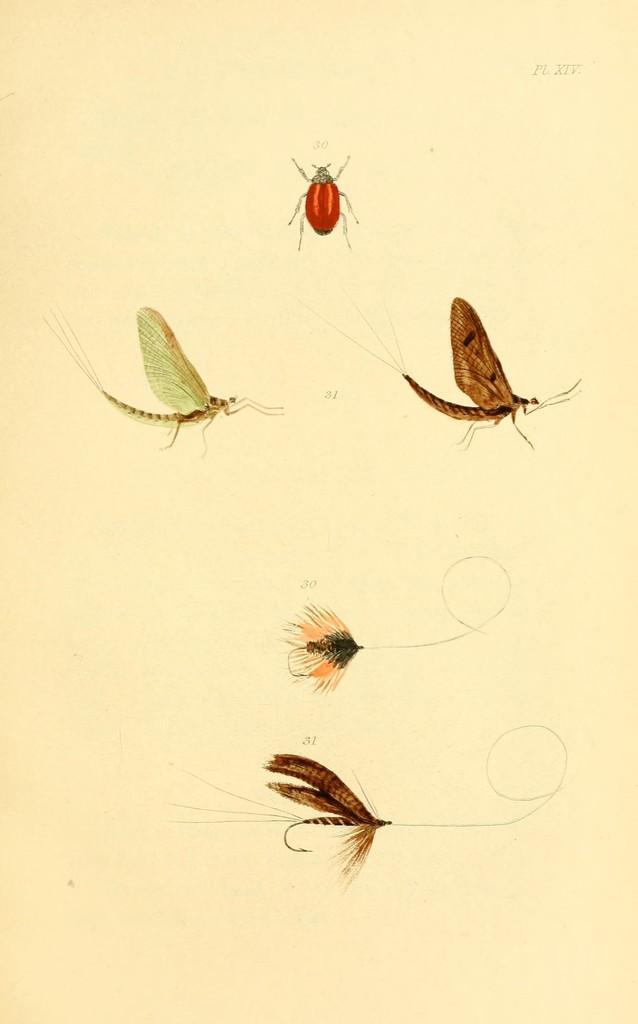How would you summarize this image in a sentence or two? This is a painting. In this image there are paintings of different insects. At the back there is a cream background. At the top right there is a text. 